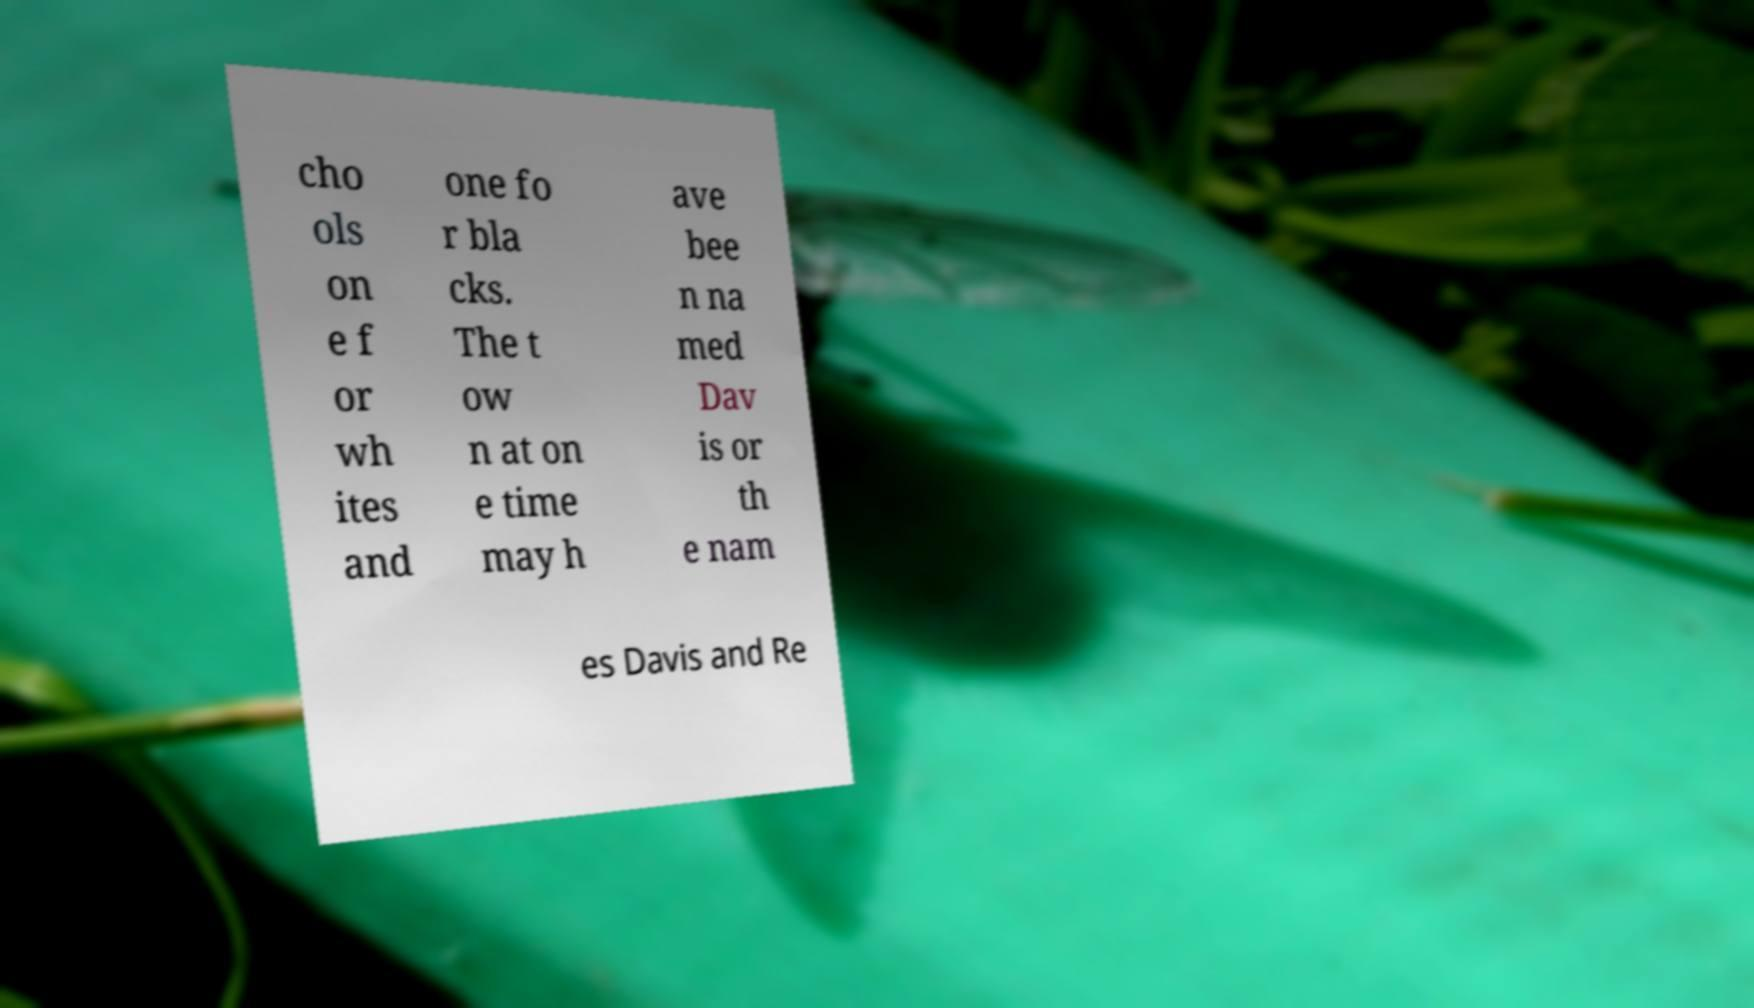I need the written content from this picture converted into text. Can you do that? cho ols on e f or wh ites and one fo r bla cks. The t ow n at on e time may h ave bee n na med Dav is or th e nam es Davis and Re 